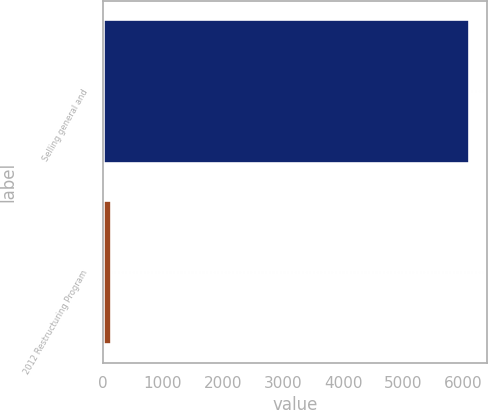Convert chart to OTSL. <chart><loc_0><loc_0><loc_500><loc_500><bar_chart><fcel>Selling general and<fcel>2012 Restructuring Program<nl><fcel>6086<fcel>137<nl></chart> 